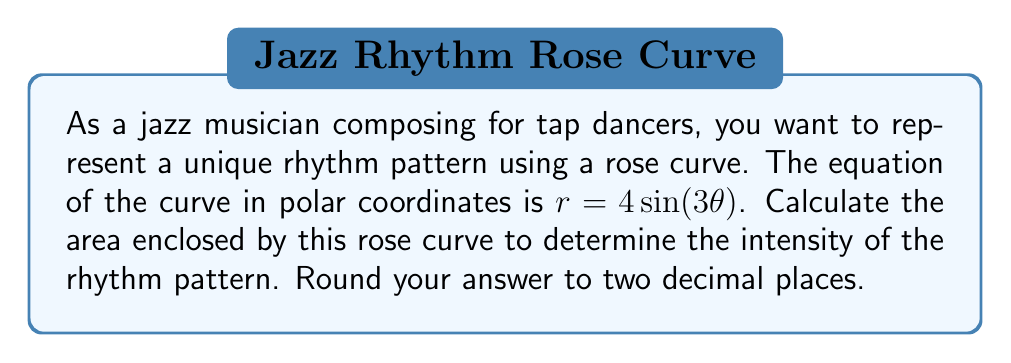Help me with this question. To calculate the area enclosed by a rose curve, we can use the formula:

$$A = \frac{1}{2} \int_0^{2\pi} r^2 d\theta$$

Where $r$ is the equation of the rose curve.

Given: $r = 4\sin(3\theta)$

Steps:
1) Square the equation of $r$:
   $r^2 = 16\sin^2(3\theta)$

2) Substitute this into the area formula:
   $$A = \frac{1}{2} \int_0^{2\pi} 16\sin^2(3\theta) d\theta$$

3) Use the trigonometric identity: $\sin^2(x) = \frac{1 - \cos(2x)}{2}$
   $$A = \frac{1}{2} \int_0^{2\pi} 16 \cdot \frac{1 - \cos(6\theta)}{2} d\theta$$

4) Simplify:
   $$A = 4 \int_0^{2\pi} (1 - \cos(6\theta)) d\theta$$

5) Integrate:
   $$A = 4 \left[ \theta - \frac{1}{6}\sin(6\theta) \right]_0^{2\pi}$$

6) Evaluate the integral:
   $$A = 4 \left[ (2\pi - 0) - \left(\frac{1}{6}\sin(12\pi) - \frac{1}{6}\sin(0)\right) \right]$$

7) Simplify:
   $$A = 4 \cdot 2\pi = 8\pi$$

8) Round to two decimal places:
   $A \approx 25.13$
Answer: $25.13$ square units 